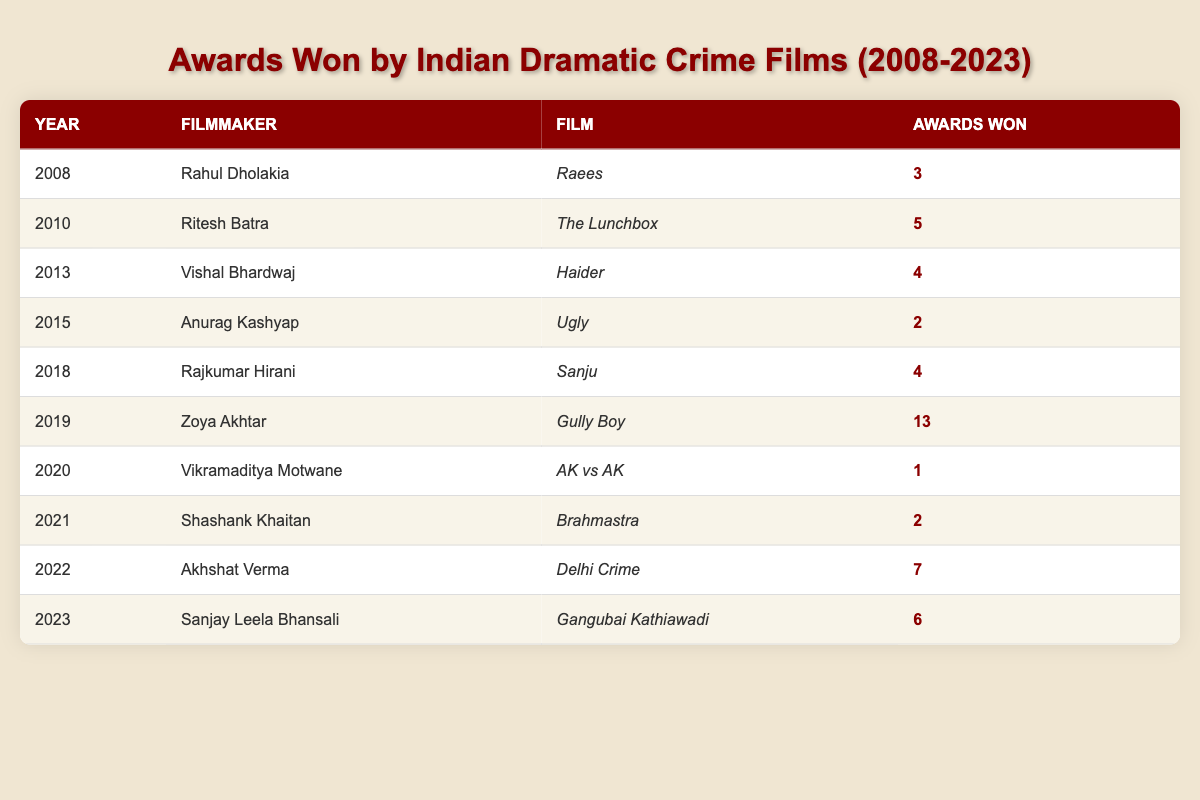What is the total number of awards won by films directed by Zoya Akhtar? Zoya Akhtar directed the film "Gully Boy" in 2019, which won 13 awards. As no other films in the table are associated with her, we take 13 as the total number of awards won.
Answer: 13 Which filmmaker won the second highest number of awards overall? The highest is Zoya Akhtar with 13 awards for "Gully Boy," and the second highest can be found by comparing the other totals. The next highest is Akhshat Verma's "Delhi Crime" with 7 awards.
Answer: Akhshat Verma How many awards were won by films released in 2018 and later? First, we identify films from 2018 onward: "Sanju" (4), "Gully Boy" (13), "AK vs AK" (1), "Brahmastra" (2), "Delhi Crime" (7), and "Gangubai Kathiawadi" (6). Summing these gives: 4 + 13 + 1 + 2 + 7 + 6 = 33.
Answer: 33 Is the statement "Anurag Kashyap's film won more awards than Rahul Dholakia's film" true? Anurag Kashyap's film "Ugly" won 2 awards, while Rahul Dholakia's film "Raees" won 3 awards. Therefore, the statement is false.
Answer: False What is the average number of awards won by films directed between 2010 and 2020? The awards won by films between these years are: 5 (2010), 4 (2013), 2 (2015), 13 (2019), and 1 (2020). The total is 5 + 4 + 2 + 13 + 1 = 25, and there are 5 films, so the average is 25/5 = 5.
Answer: 5 Which year saw the lowest number of awards won by a film? Reviewing the table, 2020 stands out with "AK vs AK" winning only 1 award. Comparing with other years, it is the lowest.
Answer: 2020 How many filmmakers in the table won awards for their films across more than one year? By checking each filmmaker, only Anurag Kashyap has directed "Ugly" (2015) and "Brahmastra" (2021), thus winning awards in more than one year. So, the count is 1.
Answer: 1 What was the total number of awards won by all films from the table? Summing all awards from the table gives: 3 + 5 + 4 + 2 + 4 + 13 + 1 + 2 + 7 + 6 = 47. There are no other films listed, confirming this sum.
Answer: 47 Which film by Rajkumar Hirani won awards? The only film by Rajkumar Hirani in the table is "Sanju," which won 4 awards. After reviewing the table, no other films by him are listed.
Answer: Sanju 